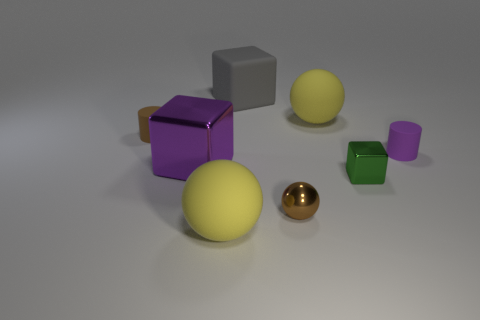Add 1 rubber cylinders. How many objects exist? 9 Subtract all cubes. How many objects are left? 5 Add 7 red metallic objects. How many red metallic objects exist? 7 Subtract 1 purple cylinders. How many objects are left? 7 Subtract all metallic blocks. Subtract all big metal things. How many objects are left? 5 Add 8 gray rubber objects. How many gray rubber objects are left? 9 